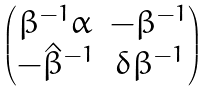<formula> <loc_0><loc_0><loc_500><loc_500>\begin{pmatrix} \beta ^ { - 1 } \alpha & - \beta ^ { - 1 } \\ - { \hat { \beta } } ^ { - 1 } & \delta \beta ^ { - 1 } \end{pmatrix}</formula> 